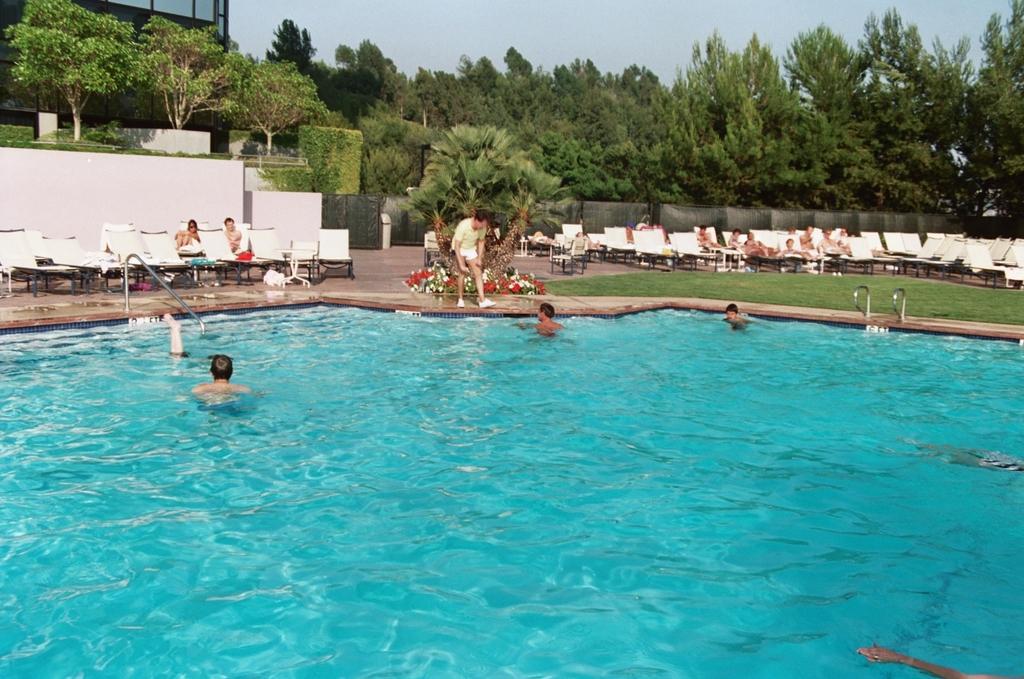Can you describe this image briefly? In this image there are group of people in swimming pool , group of people sitting on the chairs , a person standing, there is a building ,plants with flowers , trees, and in the background there is sky. 